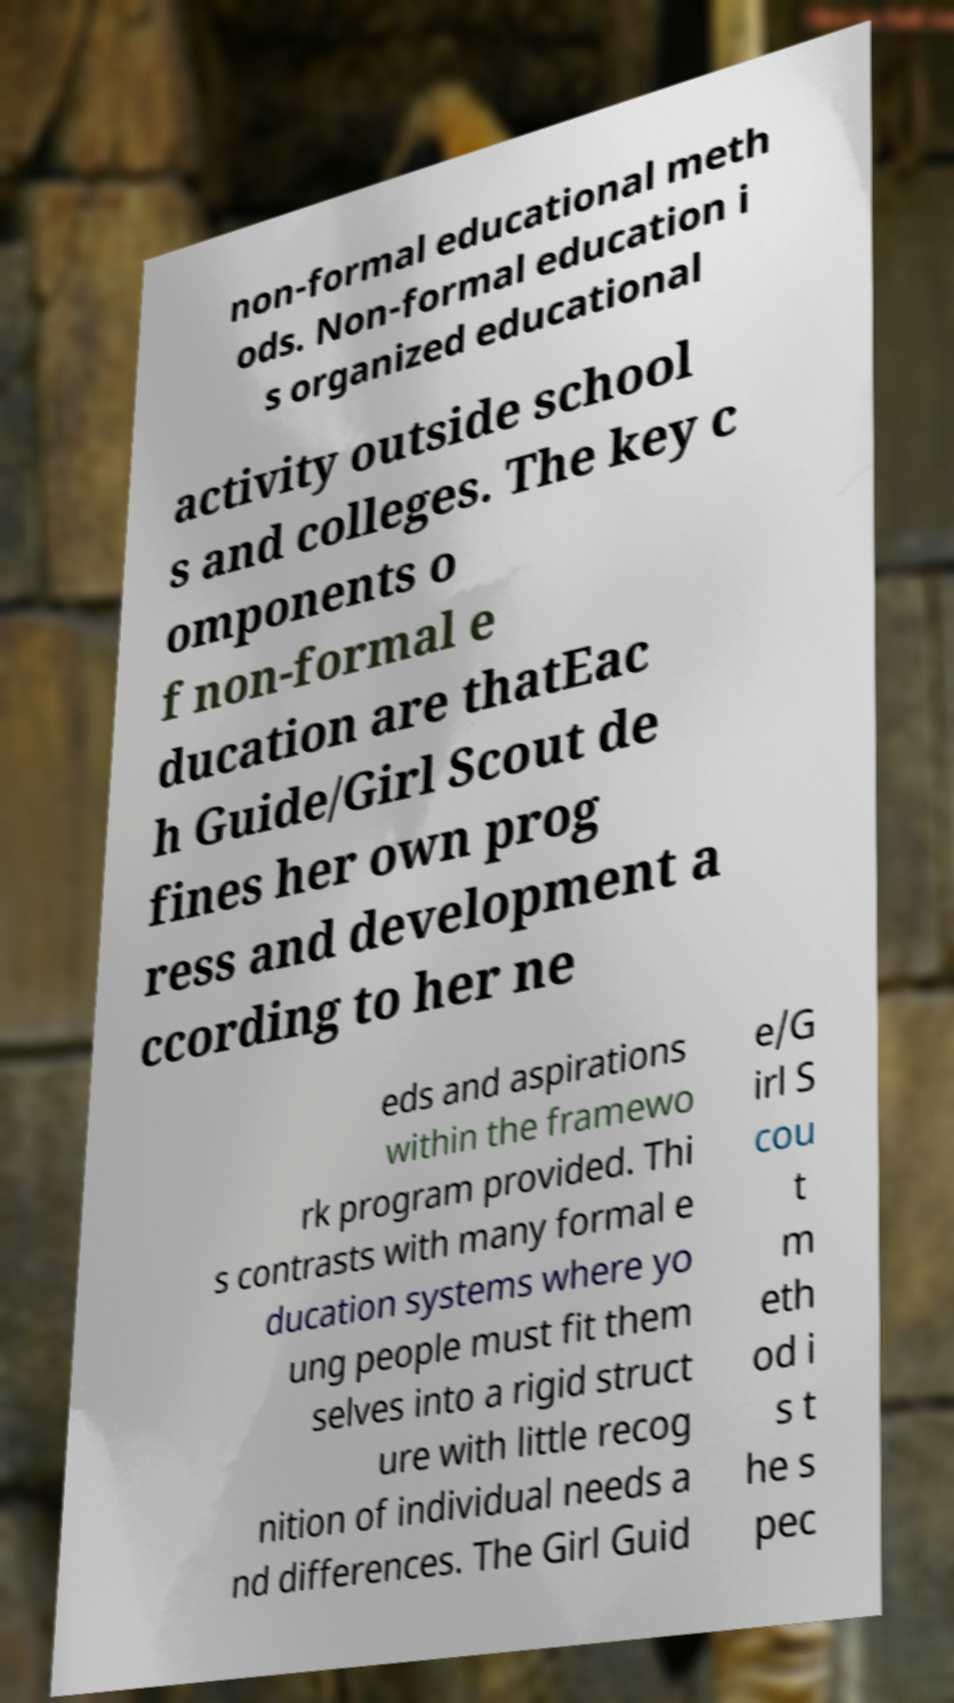I need the written content from this picture converted into text. Can you do that? non-formal educational meth ods. Non-formal education i s organized educational activity outside school s and colleges. The key c omponents o f non-formal e ducation are thatEac h Guide/Girl Scout de fines her own prog ress and development a ccording to her ne eds and aspirations within the framewo rk program provided. Thi s contrasts with many formal e ducation systems where yo ung people must fit them selves into a rigid struct ure with little recog nition of individual needs a nd differences. The Girl Guid e/G irl S cou t m eth od i s t he s pec 